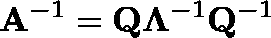Convert formula to latex. <formula><loc_0><loc_0><loc_500><loc_500>A ^ { - 1 } = Q \Lambda ^ { - 1 } Q ^ { - 1 }</formula> 